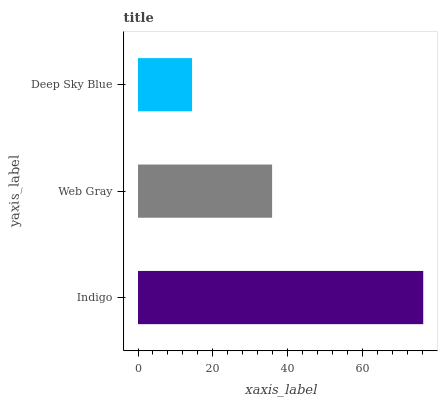Is Deep Sky Blue the minimum?
Answer yes or no. Yes. Is Indigo the maximum?
Answer yes or no. Yes. Is Web Gray the minimum?
Answer yes or no. No. Is Web Gray the maximum?
Answer yes or no. No. Is Indigo greater than Web Gray?
Answer yes or no. Yes. Is Web Gray less than Indigo?
Answer yes or no. Yes. Is Web Gray greater than Indigo?
Answer yes or no. No. Is Indigo less than Web Gray?
Answer yes or no. No. Is Web Gray the high median?
Answer yes or no. Yes. Is Web Gray the low median?
Answer yes or no. Yes. Is Deep Sky Blue the high median?
Answer yes or no. No. Is Indigo the low median?
Answer yes or no. No. 